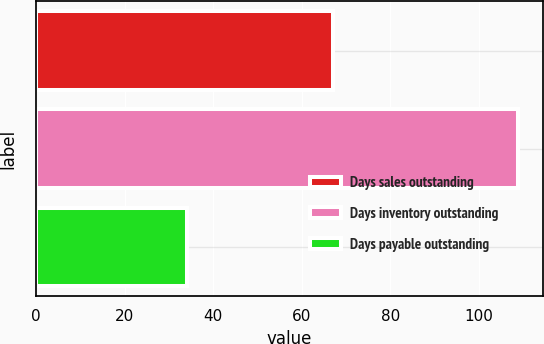<chart> <loc_0><loc_0><loc_500><loc_500><bar_chart><fcel>Days sales outstanding<fcel>Days inventory outstanding<fcel>Days payable outstanding<nl><fcel>67<fcel>109<fcel>34<nl></chart> 